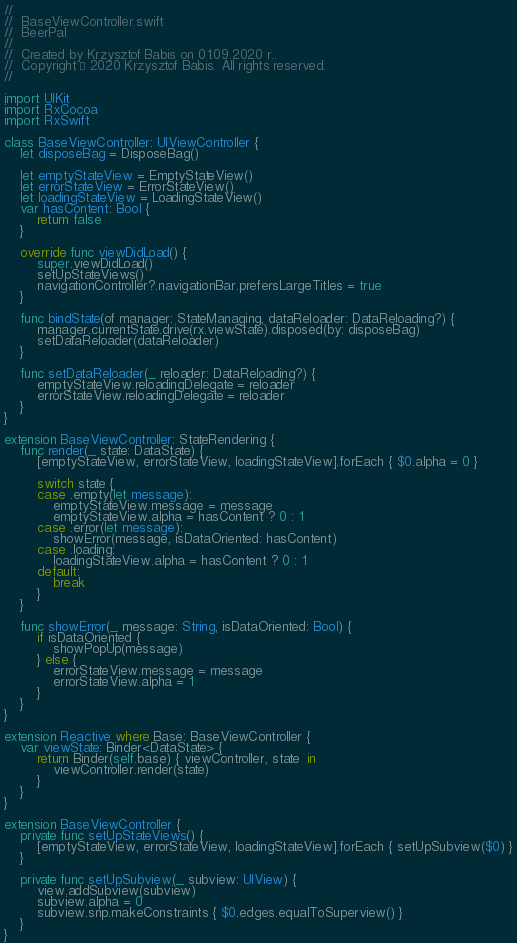Convert code to text. <code><loc_0><loc_0><loc_500><loc_500><_Swift_>//
//  BaseViewController.swift
//  BeerPal
//
//  Created by Krzysztof Babis on 01.09.2020 r..
//  Copyright © 2020 Krzysztof Babis. All rights reserved.
//

import UIKit
import RxCocoa
import RxSwift

class BaseViewController: UIViewController {
    let disposeBag = DisposeBag()
    
    let emptyStateView = EmptyStateView()
    let errorStateView = ErrorStateView()
    let loadingStateView = LoadingStateView()
    var hasContent: Bool {
        return false
    }
    
    override func viewDidLoad() {
        super.viewDidLoad()
        setUpStateViews()
        navigationController?.navigationBar.prefersLargeTitles = true
    }
    
    func bindState(of manager: StateManaging, dataReloader: DataReloading?) {
        manager.currentState.drive(rx.viewState).disposed(by: disposeBag)
        setDataReloader(dataReloader)
    }
    
    func setDataReloader(_ reloader: DataReloading?) {
        emptyStateView.reloadingDelegate = reloader
        errorStateView.reloadingDelegate = reloader
    }
}

extension BaseViewController: StateRendering {
    func render(_ state: DataState) {
        [emptyStateView, errorStateView, loadingStateView].forEach { $0.alpha = 0 }
        
        switch state {
        case .empty(let message):
            emptyStateView.message = message
            emptyStateView.alpha = hasContent ? 0 : 1
        case .error(let message):
            showError(message, isDataOriented: hasContent)
        case .loading:
            loadingStateView.alpha = hasContent ? 0 : 1
        default:
            break
        }
    }
    
    func showError(_ message: String, isDataOriented: Bool) {
        if isDataOriented {
            showPopUp(message)
        } else {
            errorStateView.message = message
            errorStateView.alpha = 1
        }
    }
}

extension Reactive where Base: BaseViewController {
    var viewState: Binder<DataState> {
        return Binder(self.base) { viewController, state  in
            viewController.render(state)
        }
    }
}

extension BaseViewController {
    private func setUpStateViews() {
        [emptyStateView, errorStateView, loadingStateView].forEach { setUpSubview($0) }
    }
    
    private func setUpSubview(_ subview: UIView) {
        view.addSubview(subview)
        subview.alpha = 0
        subview.snp.makeConstraints { $0.edges.equalToSuperview() }
    }
}
</code> 